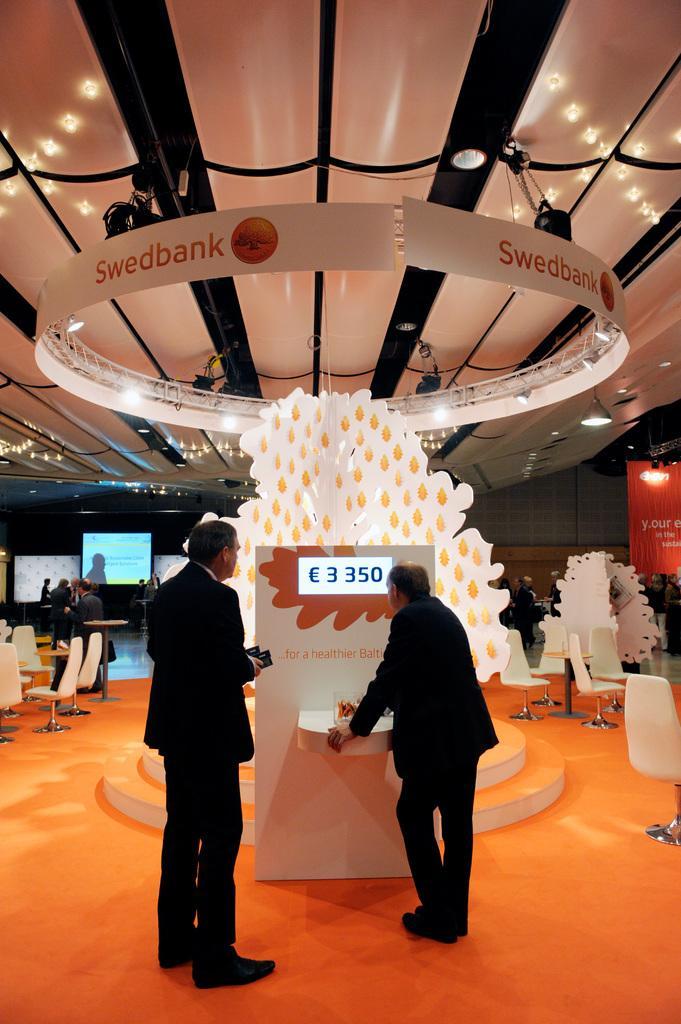In one or two sentences, can you explain what this image depicts? In this image there are two men standing, there is a man holding an object, there is a man holding an object, there is a board, there is text on the board, there is floor towards the bottom of the image, there are chairs, there is a board towards the right of the image, there are chairs towards the left of the image, there are group of persons standing, there is a screen, there is a roof towards the top of the image, there are lights. 